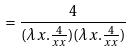<formula> <loc_0><loc_0><loc_500><loc_500>= \frac { 4 } { ( \lambda x . \frac { 4 } { x x } ) ( \lambda x . \frac { 4 } { x x } ) }</formula> 